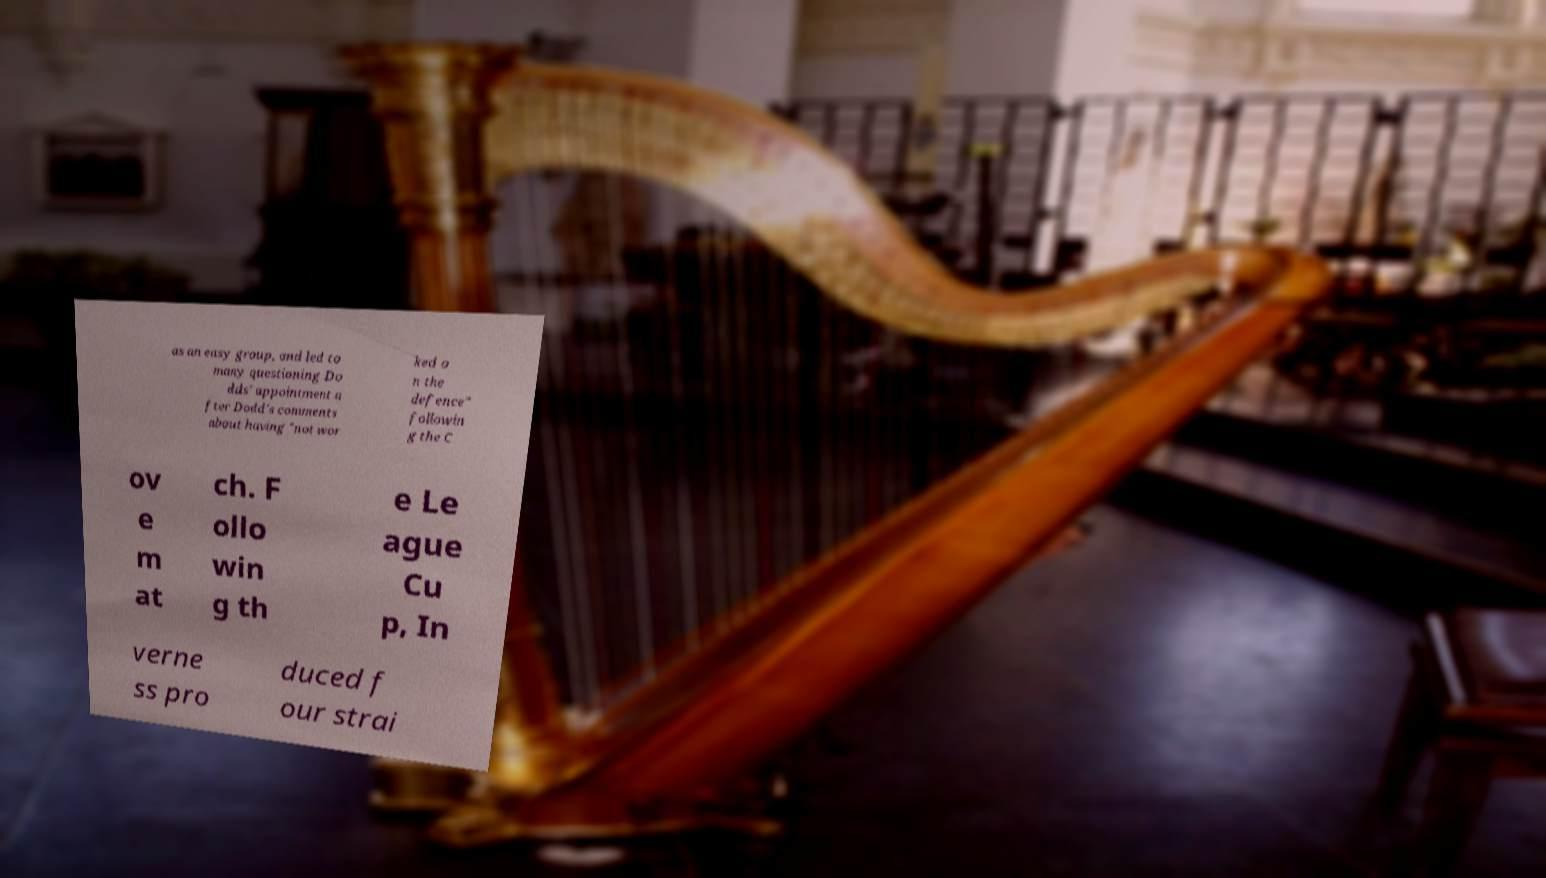Please read and relay the text visible in this image. What does it say? as an easy group, and led to many questioning Do dds' appointment a fter Dodd's comments about having "not wor ked o n the defence" followin g the C ov e m at ch. F ollo win g th e Le ague Cu p, In verne ss pro duced f our strai 